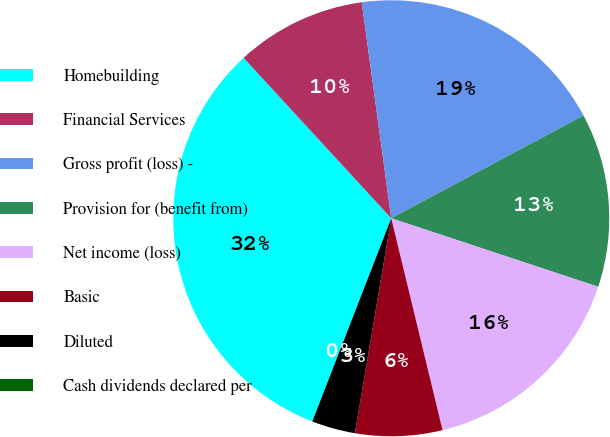Convert chart to OTSL. <chart><loc_0><loc_0><loc_500><loc_500><pie_chart><fcel>Homebuilding<fcel>Financial Services<fcel>Gross profit (loss) -<fcel>Provision for (benefit from)<fcel>Net income (loss)<fcel>Basic<fcel>Diluted<fcel>Cash dividends declared per<nl><fcel>32.26%<fcel>9.68%<fcel>19.35%<fcel>12.9%<fcel>16.13%<fcel>6.45%<fcel>3.23%<fcel>0.0%<nl></chart> 